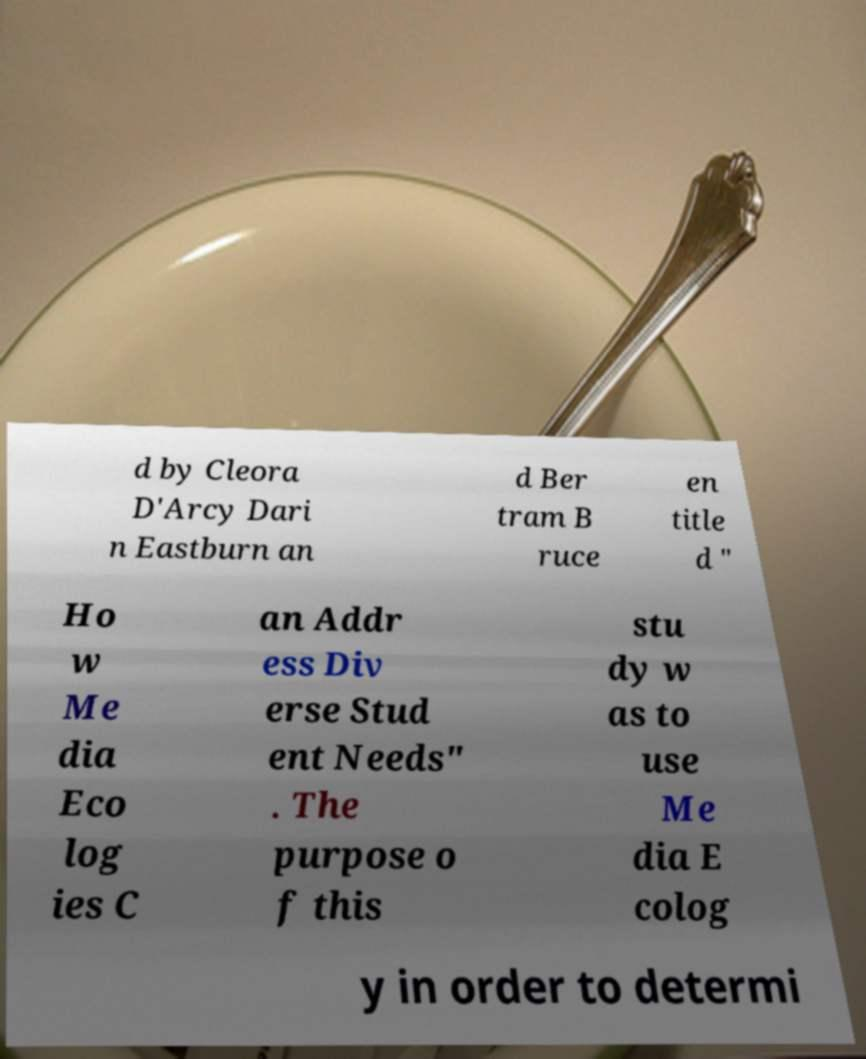I need the written content from this picture converted into text. Can you do that? d by Cleora D'Arcy Dari n Eastburn an d Ber tram B ruce en title d " Ho w Me dia Eco log ies C an Addr ess Div erse Stud ent Needs" . The purpose o f this stu dy w as to use Me dia E colog y in order to determi 